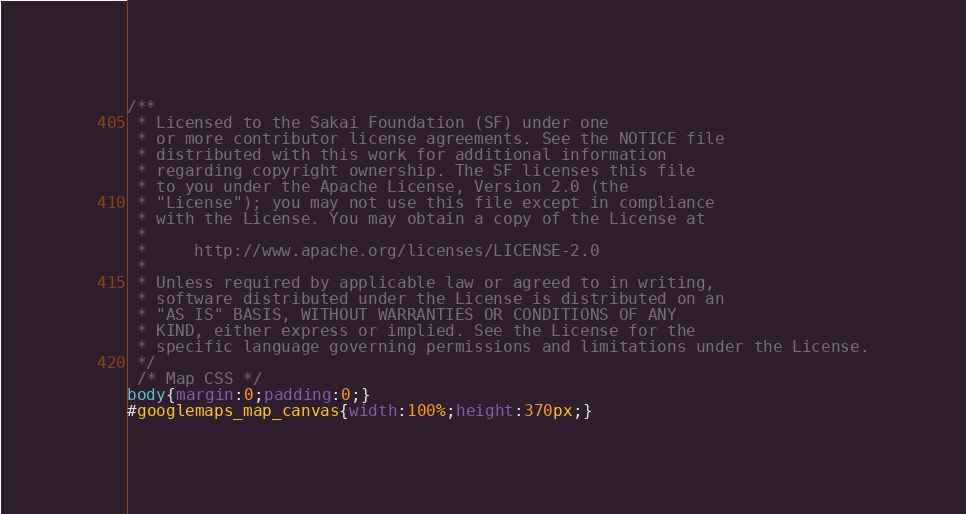<code> <loc_0><loc_0><loc_500><loc_500><_CSS_>/**
 * Licensed to the Sakai Foundation (SF) under one
 * or more contributor license agreements. See the NOTICE file
 * distributed with this work for additional information
 * regarding copyright ownership. The SF licenses this file
 * to you under the Apache License, Version 2.0 (the
 * "License"); you may not use this file except in compliance
 * with the License. You may obtain a copy of the License at
 *
 *     http://www.apache.org/licenses/LICENSE-2.0
 *
 * Unless required by applicable law or agreed to in writing,
 * software distributed under the License is distributed on an
 * "AS IS" BASIS, WITHOUT WARRANTIES OR CONDITIONS OF ANY
 * KIND, either express or implied. See the License for the
 * specific language governing permissions and limitations under the License.
 */
 /* Map CSS */
body{margin:0;padding:0;}
#googlemaps_map_canvas{width:100%;height:370px;}</code> 